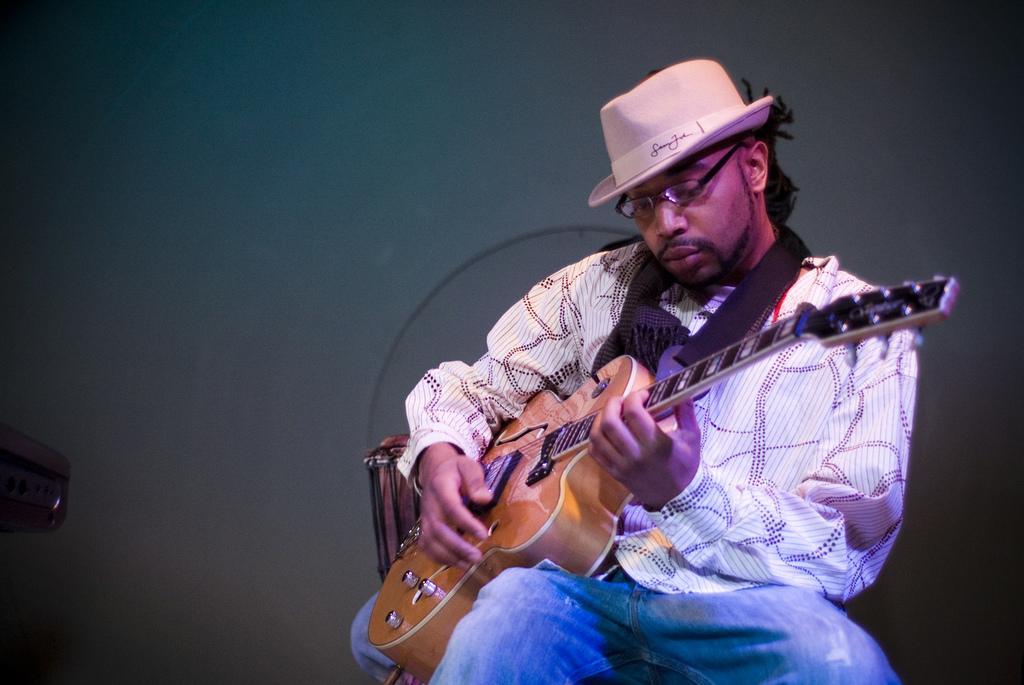Could you give a brief overview of what you see in this image? In the picture we can find a man sitting on a chair and holding the guitar and playing it. He wears a hat and he is wearing a design shirt with blue jeans pant. In the background we can find a blue wall. 